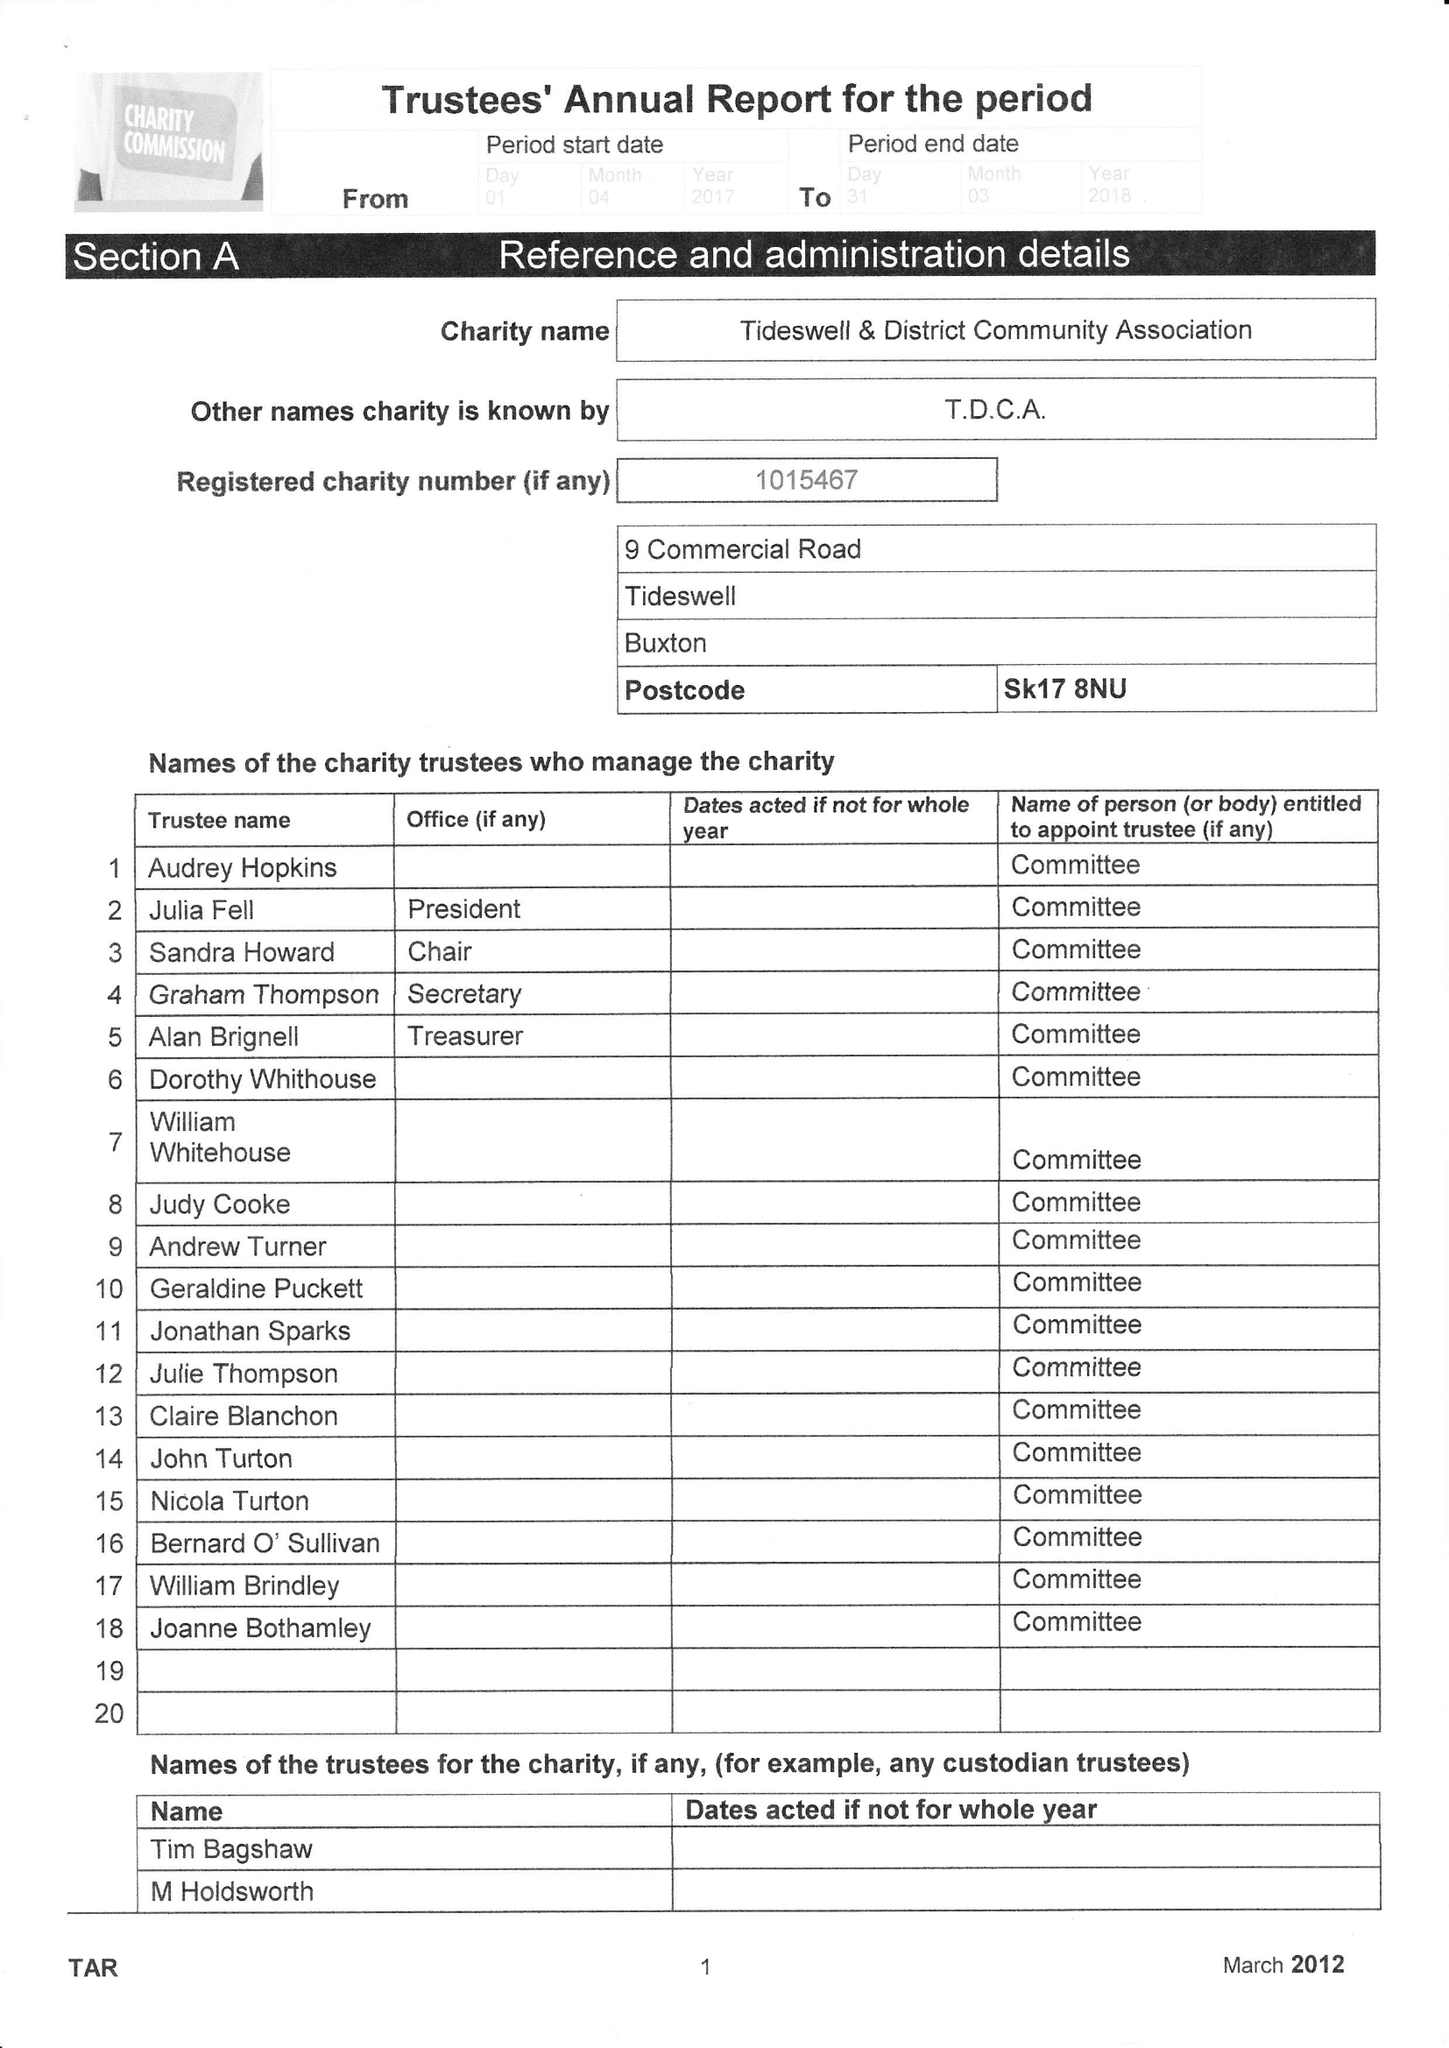What is the value for the income_annually_in_british_pounds?
Answer the question using a single word or phrase. 27838.00 